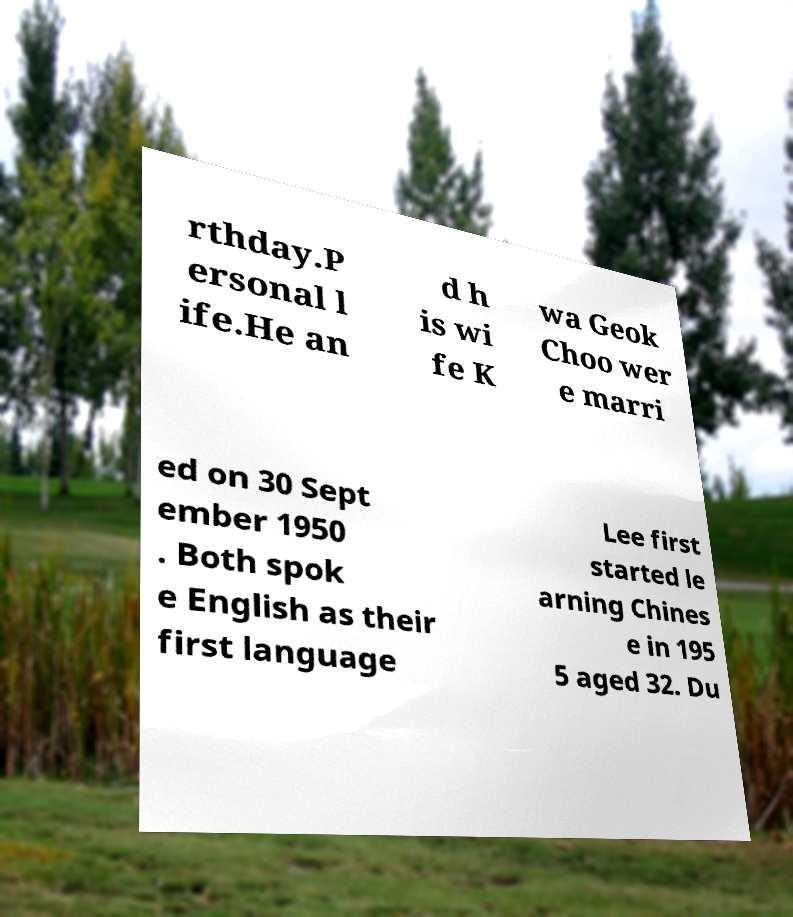Can you accurately transcribe the text from the provided image for me? rthday.P ersonal l ife.He an d h is wi fe K wa Geok Choo wer e marri ed on 30 Sept ember 1950 . Both spok e English as their first language Lee first started le arning Chines e in 195 5 aged 32. Du 